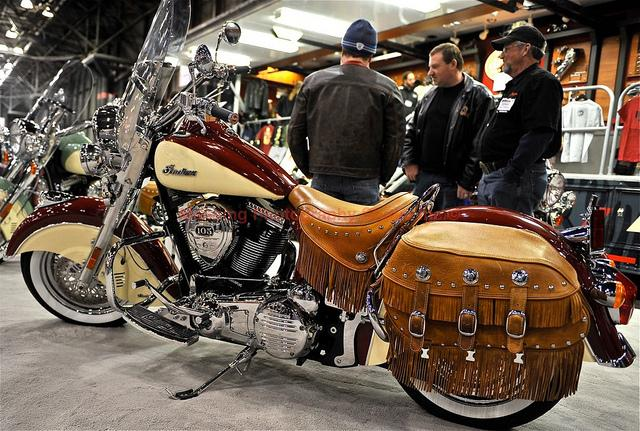What style is this bike decorated in?

Choices:
A) chef
B) golfer
C) cowboy
D) jock cowboy 